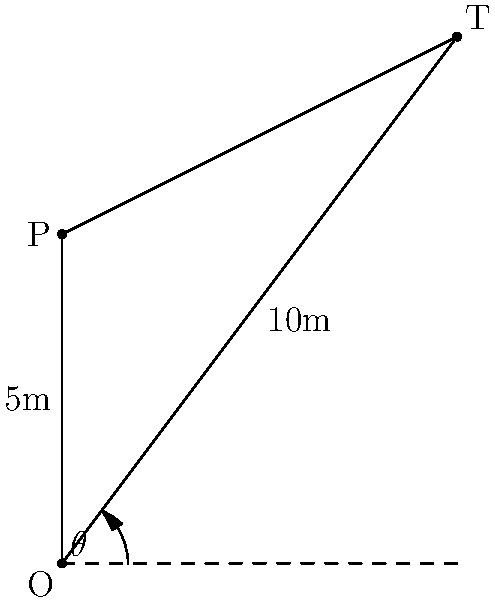As a competitive darts player, you're analyzing the optimal throw angle for a specific target. The throwing position (P) is 5 meters directly above the origin (O), and the target (T) is located 6 meters to the right and 8 meters above the origin. What is the optimal angle $\theta$ (in degrees, rounded to the nearest whole number) for the dart throw to hit the target? Let's approach this step-by-step:

1) First, we need to understand that the optimal angle for the throw will be the angle between the horizontal line from O and the line OT.

2) We can calculate this angle using the arctangent function (atan or tan^(-1)).

3) The horizontal distance from O to T is 6 meters, and the vertical distance is 8 meters.

4) The formula for calculating the angle is:

   $$\theta = \tan^{-1}(\frac{\text{vertical distance}}{\text{horizontal distance}})$$

5) Plugging in our values:

   $$\theta = \tan^{-1}(\frac{8}{6})$$

6) Using a calculator or programming function:

   $$\theta \approx 53.13010235415598^\circ$$

7) Rounding to the nearest whole number:

   $$\theta \approx 53^\circ$$

Note: This calculation gives the optimal angle from the horizontal. The actual throw will need to account for the player's position 5 meters above the origin, but the angle remains the same.
Answer: 53° 